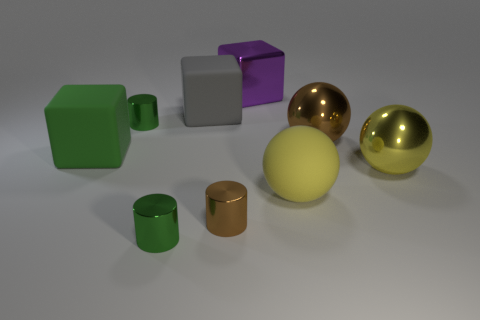There is a yellow ball right of the large brown metal thing; what is its material?
Your response must be concise. Metal. Is the brown metal cylinder the same size as the gray matte object?
Provide a succinct answer. No. Is the number of green cubes behind the brown cylinder greater than the number of big cyan shiny objects?
Your answer should be very brief. Yes. What size is the brown cylinder that is made of the same material as the large purple block?
Offer a terse response. Small. There is a big purple metal thing; are there any tiny things on the left side of it?
Your answer should be very brief. Yes. Is the shape of the big yellow metal object the same as the large gray object?
Provide a succinct answer. No. There is a matte block that is in front of the shiny sphere behind the large block in front of the gray matte block; how big is it?
Keep it short and to the point. Large. What material is the large green thing?
Your answer should be compact. Rubber. Does the large purple shiny thing have the same shape as the big gray rubber thing behind the big yellow shiny sphere?
Make the answer very short. Yes. There is a green cylinder behind the big brown ball to the right of the small thing that is in front of the tiny brown shiny cylinder; what is its material?
Offer a terse response. Metal. 